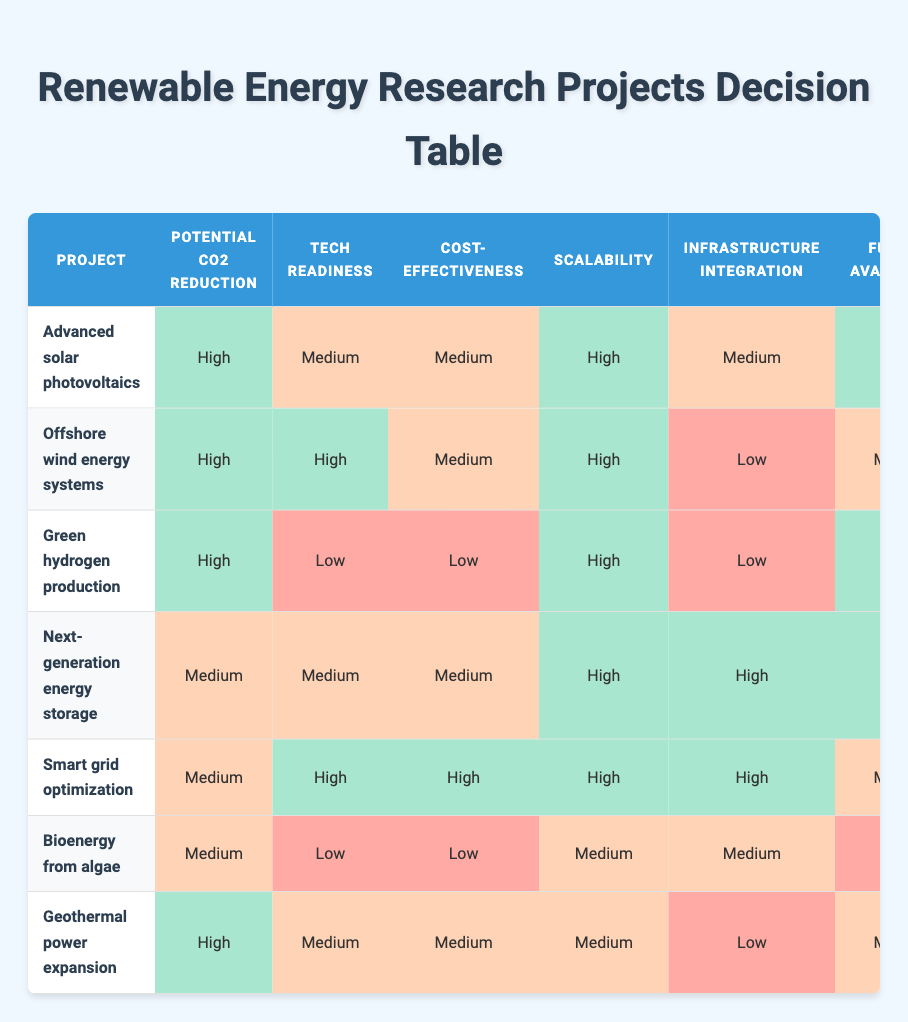What project has the highest potential CO2 reduction? By examining the "Potential CO2 Reduction" column, "Advanced solar photovoltaics," "Offshore wind energy systems," "Green hydrogen production," and "Geothermal power expansion" are all marked as "High." However, since we are looking for only one, the first project listed is "Advanced solar photovoltaics."
Answer: Advanced solar photovoltaics Which project has the lowest technological readiness level? Looking at the "Tech Readiness" column, "Green hydrogen production" and "Bioenergy from algae" are both marked as "Low." However, "Green hydrogen production" appears first in the list.
Answer: Green hydrogen production How many projects have high scalability? By reviewing the "Scalability" column, we find that "Advanced solar photovoltaics," "Offshore wind energy systems," "Green hydrogen production," "Next-generation energy storage," "Smart grid optimization," and "Geothermal power expansion" are all marked as "High." Counting these, we have six projects.
Answer: 6 Is the funding availability for "Geothermal power expansion" rated as high? Checking the "Funding Availability" column, "Geothermal power expansion" is noted as "Medium," thus it is not rated as high.
Answer: No Which project has both high funding availability and high collaboration opportunities? Reviewing the table, "Advanced solar photovoltaics," "Next-generation energy storage," and "Green hydrogen production" all have "High" ratings for both "Funding Availability" and "Collaboration Opportunities." This indicates multiple projects meet these criteria.
Answer: 3 What is the average technological readiness level of the listed projects? Assigning numerical values to categorical answers, where high = 3, medium = 2, and low = 1, we have: "Advanced solar photovoltaics" (2), "Offshore wind energy systems" (3), "Green hydrogen production" (1), "Next-generation energy storage" (2), "Smart grid optimization" (3), "Bioenergy from algae" (1), and "Geothermal power expansion" (2). The sum is 14, and there are 7 projects, so the average is 14/7 = 2.
Answer: 2 Which project has the highest cost-effectiveness rating, and what is that rating? By checking the "Cost-Effectiveness" column, "Smart grid optimization" is rated as "High," making it the project with the highest rating in this category.
Answer: Smart grid optimization, High Are there any projects with both medium-cost effectiveness and high funding availability? Looking at the table, "Next-generation energy storage" is rated as "Medium" for cost-effectiveness and "High" for funding availability. Therefore, this project meets both criteria.
Answer: Yes 